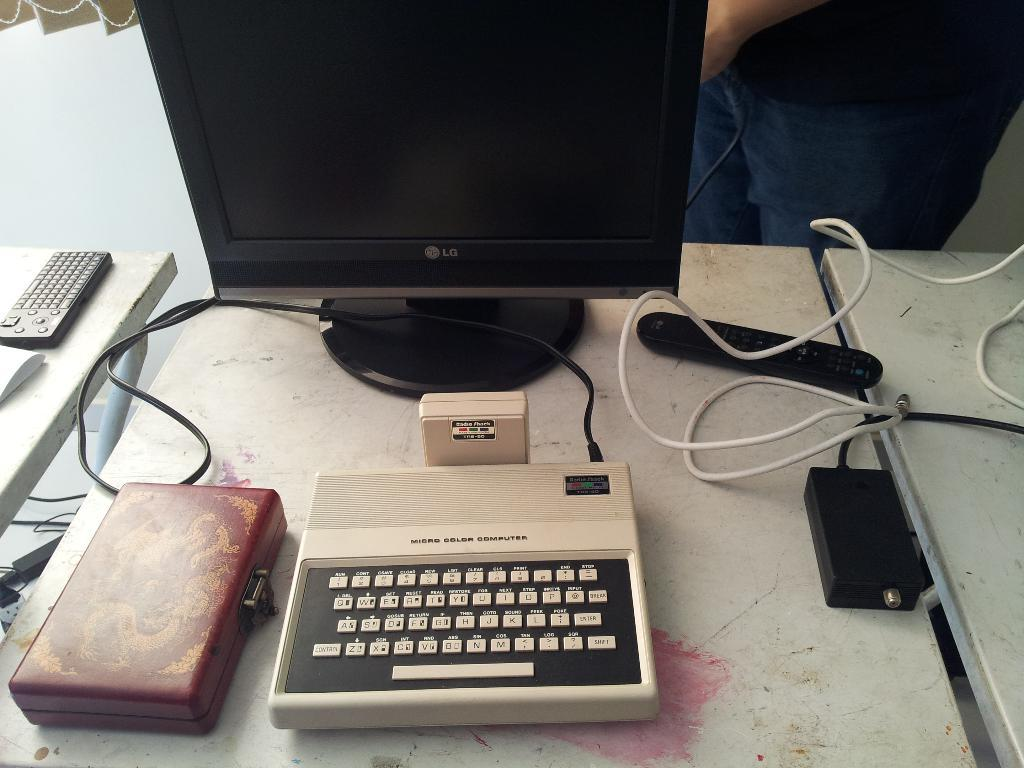<image>
Offer a succinct explanation of the picture presented. Wires attach an old Micro Color Computer to a new monitor. 